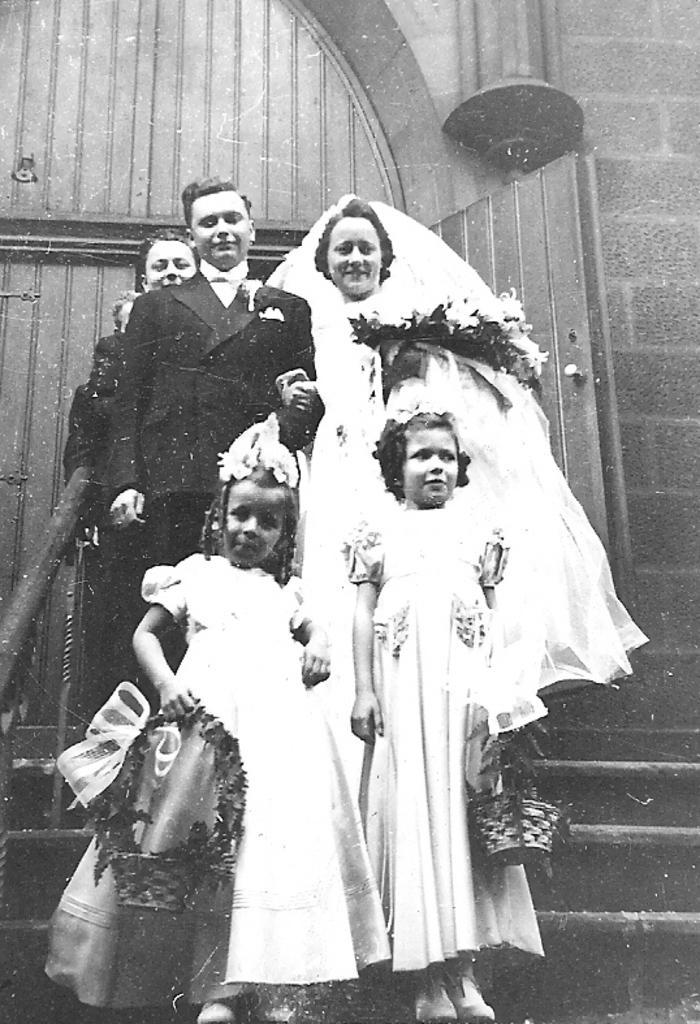Who are the main subjects in the image? There is a bride and groom in the image. What are the people on the stairs doing? The people standing on the stairs are likely observing or participating in the event involving the bride and groom. What can be seen in the background of the image? There is a building visible in the background of the image. How many potatoes are on the table in the image? There is no table or potatoes present in the image. What type of bikes are parked near the building in the image? There are no bikes present in the image. 